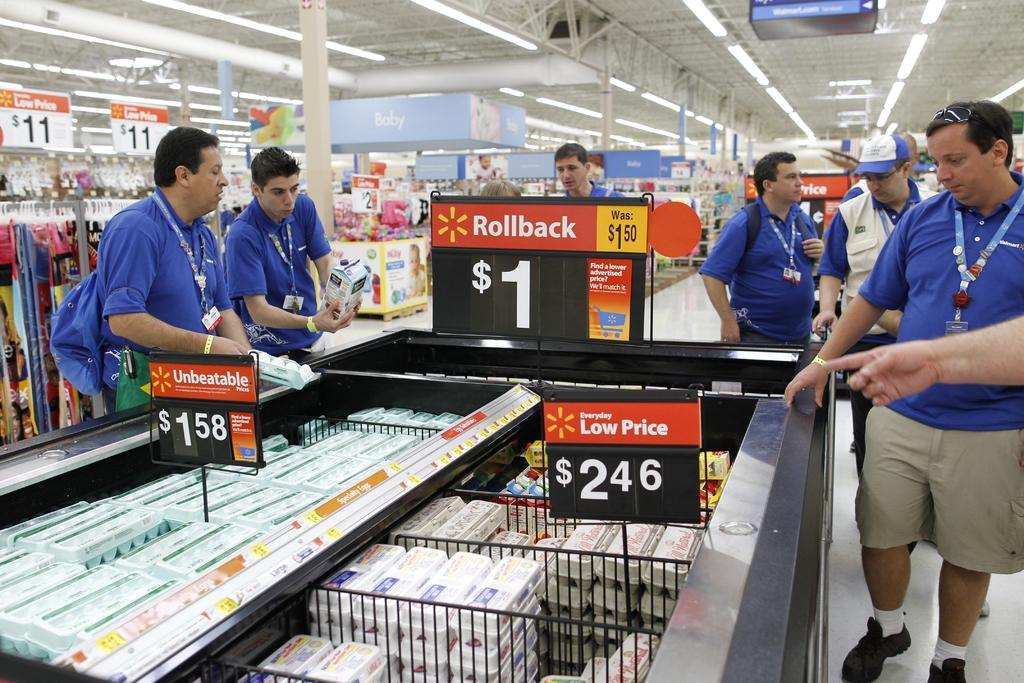<image>
Write a terse but informative summary of the picture. Walmart signs advertise rollbacks and products for $1. 